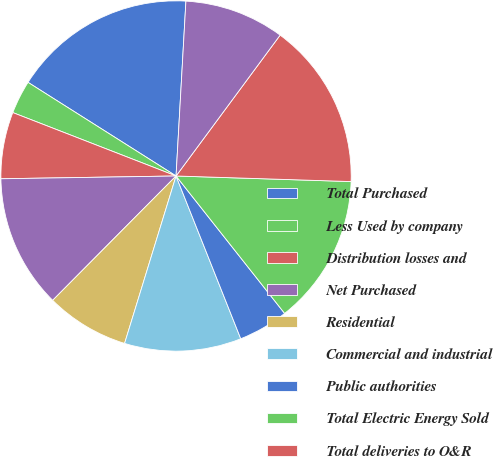<chart> <loc_0><loc_0><loc_500><loc_500><pie_chart><fcel>Total Purchased<fcel>Less Used by company<fcel>Distribution losses and<fcel>Net Purchased<fcel>Residential<fcel>Commercial and industrial<fcel>Public authorities<fcel>Total Electric Energy Sold<fcel>Total deliveries to O&R<fcel>Delivery service for retail<nl><fcel>16.92%<fcel>3.08%<fcel>6.15%<fcel>12.31%<fcel>7.69%<fcel>10.77%<fcel>4.62%<fcel>13.85%<fcel>15.38%<fcel>9.23%<nl></chart> 